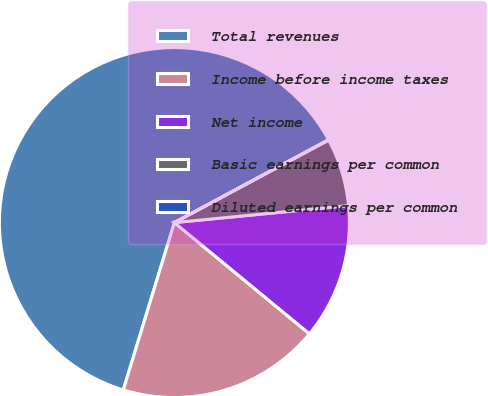Convert chart to OTSL. <chart><loc_0><loc_0><loc_500><loc_500><pie_chart><fcel>Total revenues<fcel>Income before income taxes<fcel>Net income<fcel>Basic earnings per common<fcel>Diluted earnings per common<nl><fcel>62.43%<fcel>18.75%<fcel>12.51%<fcel>6.27%<fcel>0.03%<nl></chart> 